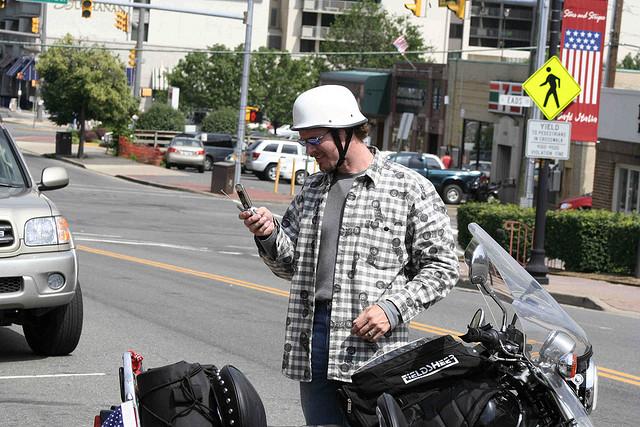What is this man doing?
Write a very short answer. Texting. What is on the man's head?
Short answer required. Helmet. What is the sign of the man in the background?
Write a very short answer. Crosswalk. 